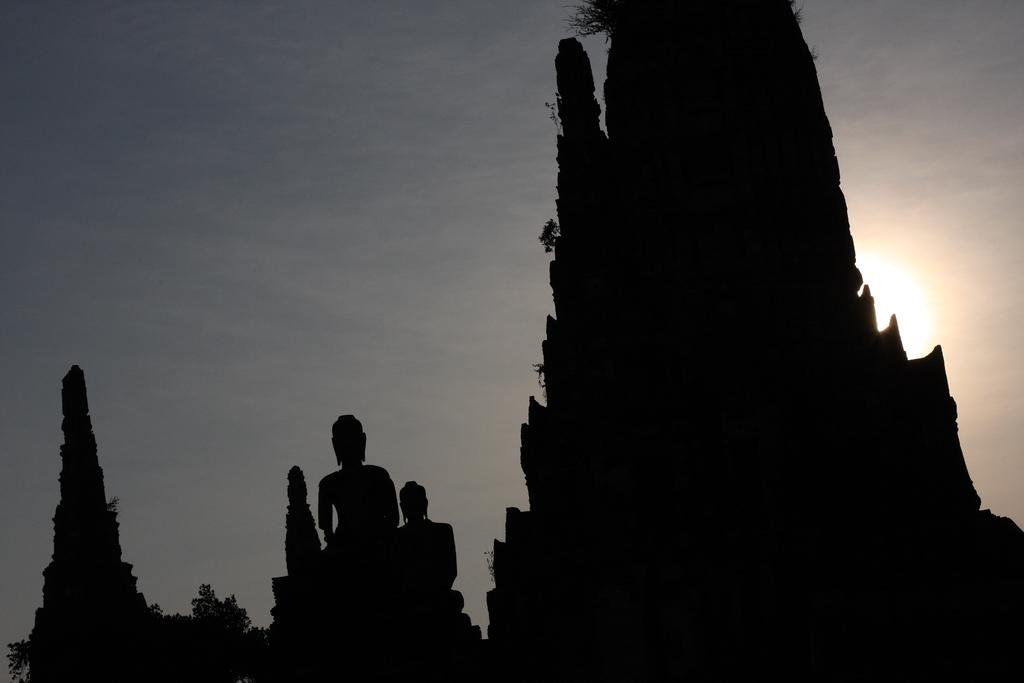What type of objects can be seen in the image? There are sculptures and monuments in the image. What is the condition of the sky in the image? The sky is cloudy in the image. What can be seen in the background of the image? There are trees in the background of the image. Can the sun be seen in the image? Yes, the sun is visible in the sky. What type of instrument is being played by the sculpture in the image? There is no instrument being played by a sculpture in the image. How many cakes are visible on the monuments in the image? There are no cakes present on the monuments in the image. 